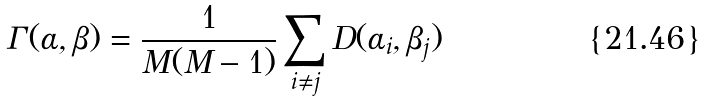<formula> <loc_0><loc_0><loc_500><loc_500>\Gamma ( \alpha , \beta ) = \frac { 1 } { M ( M - 1 ) } \sum _ { i \neq j } D ( \alpha _ { i } , \beta _ { j } )</formula> 